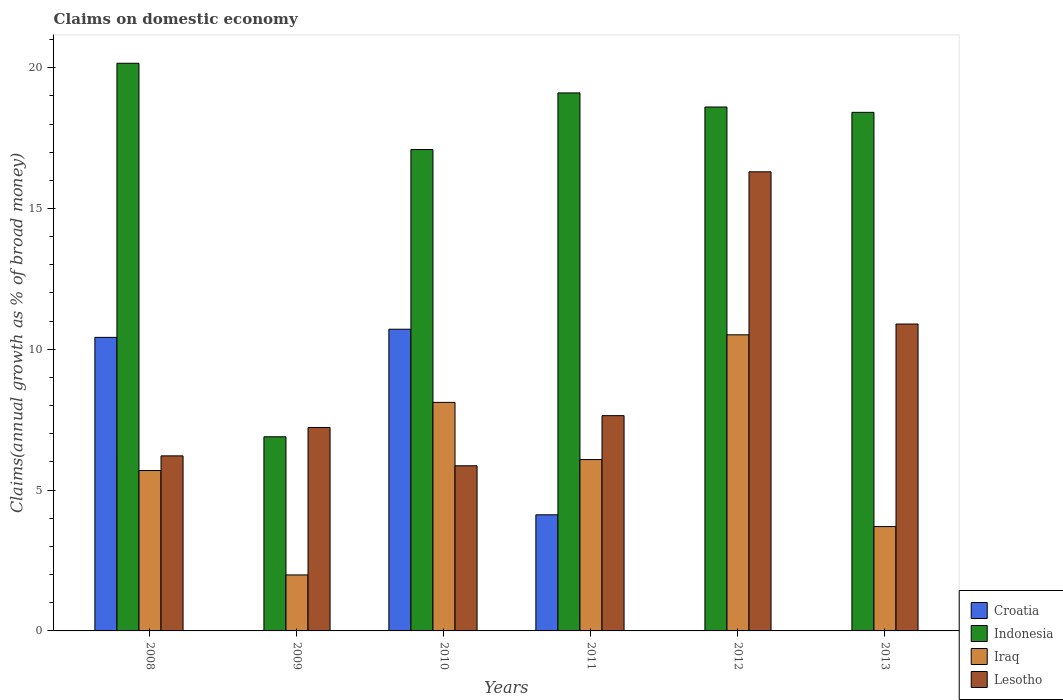How many groups of bars are there?
Offer a very short reply. 6. Are the number of bars on each tick of the X-axis equal?
Your answer should be compact. No. How many bars are there on the 4th tick from the right?
Give a very brief answer. 4. What is the label of the 4th group of bars from the left?
Offer a terse response. 2011. What is the percentage of broad money claimed on domestic economy in Croatia in 2011?
Your answer should be compact. 4.12. Across all years, what is the maximum percentage of broad money claimed on domestic economy in Lesotho?
Make the answer very short. 16.3. Across all years, what is the minimum percentage of broad money claimed on domestic economy in Lesotho?
Your answer should be compact. 5.86. In which year was the percentage of broad money claimed on domestic economy in Iraq maximum?
Your answer should be very brief. 2012. What is the total percentage of broad money claimed on domestic economy in Croatia in the graph?
Keep it short and to the point. 25.26. What is the difference between the percentage of broad money claimed on domestic economy in Indonesia in 2010 and that in 2011?
Your answer should be very brief. -2.01. What is the difference between the percentage of broad money claimed on domestic economy in Lesotho in 2012 and the percentage of broad money claimed on domestic economy in Indonesia in 2013?
Offer a very short reply. -2.11. What is the average percentage of broad money claimed on domestic economy in Iraq per year?
Keep it short and to the point. 6.02. In the year 2011, what is the difference between the percentage of broad money claimed on domestic economy in Indonesia and percentage of broad money claimed on domestic economy in Lesotho?
Make the answer very short. 11.46. In how many years, is the percentage of broad money claimed on domestic economy in Croatia greater than 20 %?
Make the answer very short. 0. What is the ratio of the percentage of broad money claimed on domestic economy in Lesotho in 2012 to that in 2013?
Your response must be concise. 1.5. What is the difference between the highest and the second highest percentage of broad money claimed on domestic economy in Indonesia?
Your answer should be compact. 1.05. What is the difference between the highest and the lowest percentage of broad money claimed on domestic economy in Croatia?
Make the answer very short. 10.71. In how many years, is the percentage of broad money claimed on domestic economy in Iraq greater than the average percentage of broad money claimed on domestic economy in Iraq taken over all years?
Ensure brevity in your answer.  3. Is the sum of the percentage of broad money claimed on domestic economy in Iraq in 2008 and 2013 greater than the maximum percentage of broad money claimed on domestic economy in Croatia across all years?
Your answer should be very brief. No. Are all the bars in the graph horizontal?
Ensure brevity in your answer.  No. What is the difference between two consecutive major ticks on the Y-axis?
Ensure brevity in your answer.  5. Are the values on the major ticks of Y-axis written in scientific E-notation?
Provide a short and direct response. No. Where does the legend appear in the graph?
Ensure brevity in your answer.  Bottom right. How are the legend labels stacked?
Make the answer very short. Vertical. What is the title of the graph?
Your response must be concise. Claims on domestic economy. What is the label or title of the X-axis?
Your answer should be very brief. Years. What is the label or title of the Y-axis?
Provide a short and direct response. Claims(annual growth as % of broad money). What is the Claims(annual growth as % of broad money) of Croatia in 2008?
Your response must be concise. 10.42. What is the Claims(annual growth as % of broad money) of Indonesia in 2008?
Offer a very short reply. 20.16. What is the Claims(annual growth as % of broad money) in Iraq in 2008?
Provide a succinct answer. 5.7. What is the Claims(annual growth as % of broad money) of Lesotho in 2008?
Offer a terse response. 6.22. What is the Claims(annual growth as % of broad money) in Croatia in 2009?
Your answer should be compact. 0. What is the Claims(annual growth as % of broad money) of Indonesia in 2009?
Give a very brief answer. 6.89. What is the Claims(annual growth as % of broad money) in Iraq in 2009?
Offer a terse response. 1.99. What is the Claims(annual growth as % of broad money) in Lesotho in 2009?
Give a very brief answer. 7.22. What is the Claims(annual growth as % of broad money) of Croatia in 2010?
Your response must be concise. 10.71. What is the Claims(annual growth as % of broad money) in Indonesia in 2010?
Make the answer very short. 17.1. What is the Claims(annual growth as % of broad money) of Iraq in 2010?
Your response must be concise. 8.12. What is the Claims(annual growth as % of broad money) of Lesotho in 2010?
Provide a short and direct response. 5.86. What is the Claims(annual growth as % of broad money) in Croatia in 2011?
Provide a short and direct response. 4.12. What is the Claims(annual growth as % of broad money) of Indonesia in 2011?
Make the answer very short. 19.1. What is the Claims(annual growth as % of broad money) in Iraq in 2011?
Ensure brevity in your answer.  6.09. What is the Claims(annual growth as % of broad money) in Lesotho in 2011?
Give a very brief answer. 7.64. What is the Claims(annual growth as % of broad money) of Croatia in 2012?
Make the answer very short. 0. What is the Claims(annual growth as % of broad money) in Indonesia in 2012?
Keep it short and to the point. 18.6. What is the Claims(annual growth as % of broad money) of Iraq in 2012?
Provide a succinct answer. 10.51. What is the Claims(annual growth as % of broad money) of Lesotho in 2012?
Provide a short and direct response. 16.3. What is the Claims(annual growth as % of broad money) of Croatia in 2013?
Ensure brevity in your answer.  0. What is the Claims(annual growth as % of broad money) in Indonesia in 2013?
Provide a short and direct response. 18.42. What is the Claims(annual growth as % of broad money) in Iraq in 2013?
Keep it short and to the point. 3.71. What is the Claims(annual growth as % of broad money) in Lesotho in 2013?
Your answer should be compact. 10.9. Across all years, what is the maximum Claims(annual growth as % of broad money) in Croatia?
Make the answer very short. 10.71. Across all years, what is the maximum Claims(annual growth as % of broad money) in Indonesia?
Make the answer very short. 20.16. Across all years, what is the maximum Claims(annual growth as % of broad money) of Iraq?
Provide a succinct answer. 10.51. Across all years, what is the maximum Claims(annual growth as % of broad money) in Lesotho?
Give a very brief answer. 16.3. Across all years, what is the minimum Claims(annual growth as % of broad money) of Indonesia?
Give a very brief answer. 6.89. Across all years, what is the minimum Claims(annual growth as % of broad money) of Iraq?
Your answer should be very brief. 1.99. Across all years, what is the minimum Claims(annual growth as % of broad money) of Lesotho?
Make the answer very short. 5.86. What is the total Claims(annual growth as % of broad money) of Croatia in the graph?
Provide a short and direct response. 25.26. What is the total Claims(annual growth as % of broad money) in Indonesia in the graph?
Your answer should be very brief. 100.27. What is the total Claims(annual growth as % of broad money) in Iraq in the graph?
Make the answer very short. 36.11. What is the total Claims(annual growth as % of broad money) of Lesotho in the graph?
Ensure brevity in your answer.  54.15. What is the difference between the Claims(annual growth as % of broad money) of Indonesia in 2008 and that in 2009?
Your response must be concise. 13.26. What is the difference between the Claims(annual growth as % of broad money) in Iraq in 2008 and that in 2009?
Your response must be concise. 3.71. What is the difference between the Claims(annual growth as % of broad money) in Lesotho in 2008 and that in 2009?
Your response must be concise. -1.01. What is the difference between the Claims(annual growth as % of broad money) in Croatia in 2008 and that in 2010?
Your response must be concise. -0.29. What is the difference between the Claims(annual growth as % of broad money) in Indonesia in 2008 and that in 2010?
Provide a short and direct response. 3.06. What is the difference between the Claims(annual growth as % of broad money) of Iraq in 2008 and that in 2010?
Offer a very short reply. -2.42. What is the difference between the Claims(annual growth as % of broad money) in Lesotho in 2008 and that in 2010?
Offer a very short reply. 0.35. What is the difference between the Claims(annual growth as % of broad money) in Croatia in 2008 and that in 2011?
Your answer should be compact. 6.3. What is the difference between the Claims(annual growth as % of broad money) in Indonesia in 2008 and that in 2011?
Your response must be concise. 1.05. What is the difference between the Claims(annual growth as % of broad money) of Iraq in 2008 and that in 2011?
Provide a short and direct response. -0.39. What is the difference between the Claims(annual growth as % of broad money) of Lesotho in 2008 and that in 2011?
Offer a terse response. -1.43. What is the difference between the Claims(annual growth as % of broad money) in Indonesia in 2008 and that in 2012?
Offer a terse response. 1.55. What is the difference between the Claims(annual growth as % of broad money) in Iraq in 2008 and that in 2012?
Give a very brief answer. -4.82. What is the difference between the Claims(annual growth as % of broad money) of Lesotho in 2008 and that in 2012?
Keep it short and to the point. -10.09. What is the difference between the Claims(annual growth as % of broad money) in Indonesia in 2008 and that in 2013?
Provide a short and direct response. 1.74. What is the difference between the Claims(annual growth as % of broad money) of Iraq in 2008 and that in 2013?
Ensure brevity in your answer.  1.99. What is the difference between the Claims(annual growth as % of broad money) in Lesotho in 2008 and that in 2013?
Offer a terse response. -4.68. What is the difference between the Claims(annual growth as % of broad money) in Indonesia in 2009 and that in 2010?
Make the answer very short. -10.2. What is the difference between the Claims(annual growth as % of broad money) in Iraq in 2009 and that in 2010?
Provide a succinct answer. -6.13. What is the difference between the Claims(annual growth as % of broad money) in Lesotho in 2009 and that in 2010?
Provide a short and direct response. 1.36. What is the difference between the Claims(annual growth as % of broad money) in Indonesia in 2009 and that in 2011?
Keep it short and to the point. -12.21. What is the difference between the Claims(annual growth as % of broad money) in Iraq in 2009 and that in 2011?
Give a very brief answer. -4.1. What is the difference between the Claims(annual growth as % of broad money) of Lesotho in 2009 and that in 2011?
Your answer should be very brief. -0.42. What is the difference between the Claims(annual growth as % of broad money) in Indonesia in 2009 and that in 2012?
Provide a short and direct response. -11.71. What is the difference between the Claims(annual growth as % of broad money) in Iraq in 2009 and that in 2012?
Give a very brief answer. -8.53. What is the difference between the Claims(annual growth as % of broad money) in Lesotho in 2009 and that in 2012?
Your answer should be very brief. -9.08. What is the difference between the Claims(annual growth as % of broad money) of Indonesia in 2009 and that in 2013?
Keep it short and to the point. -11.52. What is the difference between the Claims(annual growth as % of broad money) in Iraq in 2009 and that in 2013?
Give a very brief answer. -1.72. What is the difference between the Claims(annual growth as % of broad money) in Lesotho in 2009 and that in 2013?
Your answer should be very brief. -3.67. What is the difference between the Claims(annual growth as % of broad money) in Croatia in 2010 and that in 2011?
Give a very brief answer. 6.59. What is the difference between the Claims(annual growth as % of broad money) in Indonesia in 2010 and that in 2011?
Provide a short and direct response. -2.01. What is the difference between the Claims(annual growth as % of broad money) of Iraq in 2010 and that in 2011?
Offer a terse response. 2.03. What is the difference between the Claims(annual growth as % of broad money) in Lesotho in 2010 and that in 2011?
Offer a terse response. -1.78. What is the difference between the Claims(annual growth as % of broad money) of Indonesia in 2010 and that in 2012?
Keep it short and to the point. -1.51. What is the difference between the Claims(annual growth as % of broad money) in Iraq in 2010 and that in 2012?
Your answer should be very brief. -2.4. What is the difference between the Claims(annual growth as % of broad money) of Lesotho in 2010 and that in 2012?
Give a very brief answer. -10.44. What is the difference between the Claims(annual growth as % of broad money) in Indonesia in 2010 and that in 2013?
Your answer should be compact. -1.32. What is the difference between the Claims(annual growth as % of broad money) in Iraq in 2010 and that in 2013?
Offer a very short reply. 4.41. What is the difference between the Claims(annual growth as % of broad money) of Lesotho in 2010 and that in 2013?
Offer a very short reply. -5.03. What is the difference between the Claims(annual growth as % of broad money) of Iraq in 2011 and that in 2012?
Give a very brief answer. -4.43. What is the difference between the Claims(annual growth as % of broad money) in Lesotho in 2011 and that in 2012?
Make the answer very short. -8.66. What is the difference between the Claims(annual growth as % of broad money) in Indonesia in 2011 and that in 2013?
Your response must be concise. 0.69. What is the difference between the Claims(annual growth as % of broad money) of Iraq in 2011 and that in 2013?
Provide a succinct answer. 2.38. What is the difference between the Claims(annual growth as % of broad money) of Lesotho in 2011 and that in 2013?
Make the answer very short. -3.25. What is the difference between the Claims(annual growth as % of broad money) in Indonesia in 2012 and that in 2013?
Offer a very short reply. 0.19. What is the difference between the Claims(annual growth as % of broad money) in Iraq in 2012 and that in 2013?
Offer a terse response. 6.81. What is the difference between the Claims(annual growth as % of broad money) in Lesotho in 2012 and that in 2013?
Give a very brief answer. 5.41. What is the difference between the Claims(annual growth as % of broad money) in Croatia in 2008 and the Claims(annual growth as % of broad money) in Indonesia in 2009?
Offer a terse response. 3.53. What is the difference between the Claims(annual growth as % of broad money) in Croatia in 2008 and the Claims(annual growth as % of broad money) in Iraq in 2009?
Provide a short and direct response. 8.44. What is the difference between the Claims(annual growth as % of broad money) of Croatia in 2008 and the Claims(annual growth as % of broad money) of Lesotho in 2009?
Your answer should be compact. 3.2. What is the difference between the Claims(annual growth as % of broad money) of Indonesia in 2008 and the Claims(annual growth as % of broad money) of Iraq in 2009?
Provide a succinct answer. 18.17. What is the difference between the Claims(annual growth as % of broad money) of Indonesia in 2008 and the Claims(annual growth as % of broad money) of Lesotho in 2009?
Your answer should be very brief. 12.93. What is the difference between the Claims(annual growth as % of broad money) in Iraq in 2008 and the Claims(annual growth as % of broad money) in Lesotho in 2009?
Ensure brevity in your answer.  -1.53. What is the difference between the Claims(annual growth as % of broad money) in Croatia in 2008 and the Claims(annual growth as % of broad money) in Indonesia in 2010?
Give a very brief answer. -6.67. What is the difference between the Claims(annual growth as % of broad money) of Croatia in 2008 and the Claims(annual growth as % of broad money) of Iraq in 2010?
Give a very brief answer. 2.31. What is the difference between the Claims(annual growth as % of broad money) in Croatia in 2008 and the Claims(annual growth as % of broad money) in Lesotho in 2010?
Provide a succinct answer. 4.56. What is the difference between the Claims(annual growth as % of broad money) in Indonesia in 2008 and the Claims(annual growth as % of broad money) in Iraq in 2010?
Your answer should be very brief. 12.04. What is the difference between the Claims(annual growth as % of broad money) in Indonesia in 2008 and the Claims(annual growth as % of broad money) in Lesotho in 2010?
Your answer should be compact. 14.29. What is the difference between the Claims(annual growth as % of broad money) of Iraq in 2008 and the Claims(annual growth as % of broad money) of Lesotho in 2010?
Offer a very short reply. -0.17. What is the difference between the Claims(annual growth as % of broad money) in Croatia in 2008 and the Claims(annual growth as % of broad money) in Indonesia in 2011?
Your answer should be very brief. -8.68. What is the difference between the Claims(annual growth as % of broad money) of Croatia in 2008 and the Claims(annual growth as % of broad money) of Iraq in 2011?
Provide a succinct answer. 4.34. What is the difference between the Claims(annual growth as % of broad money) in Croatia in 2008 and the Claims(annual growth as % of broad money) in Lesotho in 2011?
Your response must be concise. 2.78. What is the difference between the Claims(annual growth as % of broad money) in Indonesia in 2008 and the Claims(annual growth as % of broad money) in Iraq in 2011?
Your response must be concise. 14.07. What is the difference between the Claims(annual growth as % of broad money) in Indonesia in 2008 and the Claims(annual growth as % of broad money) in Lesotho in 2011?
Provide a short and direct response. 12.51. What is the difference between the Claims(annual growth as % of broad money) in Iraq in 2008 and the Claims(annual growth as % of broad money) in Lesotho in 2011?
Provide a short and direct response. -1.95. What is the difference between the Claims(annual growth as % of broad money) in Croatia in 2008 and the Claims(annual growth as % of broad money) in Indonesia in 2012?
Offer a very short reply. -8.18. What is the difference between the Claims(annual growth as % of broad money) of Croatia in 2008 and the Claims(annual growth as % of broad money) of Iraq in 2012?
Offer a terse response. -0.09. What is the difference between the Claims(annual growth as % of broad money) in Croatia in 2008 and the Claims(annual growth as % of broad money) in Lesotho in 2012?
Provide a succinct answer. -5.88. What is the difference between the Claims(annual growth as % of broad money) of Indonesia in 2008 and the Claims(annual growth as % of broad money) of Iraq in 2012?
Your response must be concise. 9.64. What is the difference between the Claims(annual growth as % of broad money) of Indonesia in 2008 and the Claims(annual growth as % of broad money) of Lesotho in 2012?
Offer a very short reply. 3.85. What is the difference between the Claims(annual growth as % of broad money) in Iraq in 2008 and the Claims(annual growth as % of broad money) in Lesotho in 2012?
Offer a terse response. -10.61. What is the difference between the Claims(annual growth as % of broad money) of Croatia in 2008 and the Claims(annual growth as % of broad money) of Indonesia in 2013?
Provide a short and direct response. -7.99. What is the difference between the Claims(annual growth as % of broad money) in Croatia in 2008 and the Claims(annual growth as % of broad money) in Iraq in 2013?
Ensure brevity in your answer.  6.72. What is the difference between the Claims(annual growth as % of broad money) in Croatia in 2008 and the Claims(annual growth as % of broad money) in Lesotho in 2013?
Keep it short and to the point. -0.47. What is the difference between the Claims(annual growth as % of broad money) of Indonesia in 2008 and the Claims(annual growth as % of broad money) of Iraq in 2013?
Your response must be concise. 16.45. What is the difference between the Claims(annual growth as % of broad money) in Indonesia in 2008 and the Claims(annual growth as % of broad money) in Lesotho in 2013?
Provide a succinct answer. 9.26. What is the difference between the Claims(annual growth as % of broad money) of Iraq in 2008 and the Claims(annual growth as % of broad money) of Lesotho in 2013?
Keep it short and to the point. -5.2. What is the difference between the Claims(annual growth as % of broad money) in Indonesia in 2009 and the Claims(annual growth as % of broad money) in Iraq in 2010?
Offer a very short reply. -1.22. What is the difference between the Claims(annual growth as % of broad money) of Indonesia in 2009 and the Claims(annual growth as % of broad money) of Lesotho in 2010?
Provide a succinct answer. 1.03. What is the difference between the Claims(annual growth as % of broad money) of Iraq in 2009 and the Claims(annual growth as % of broad money) of Lesotho in 2010?
Ensure brevity in your answer.  -3.88. What is the difference between the Claims(annual growth as % of broad money) of Indonesia in 2009 and the Claims(annual growth as % of broad money) of Iraq in 2011?
Provide a succinct answer. 0.81. What is the difference between the Claims(annual growth as % of broad money) in Indonesia in 2009 and the Claims(annual growth as % of broad money) in Lesotho in 2011?
Your answer should be compact. -0.75. What is the difference between the Claims(annual growth as % of broad money) in Iraq in 2009 and the Claims(annual growth as % of broad money) in Lesotho in 2011?
Your response must be concise. -5.66. What is the difference between the Claims(annual growth as % of broad money) of Indonesia in 2009 and the Claims(annual growth as % of broad money) of Iraq in 2012?
Your response must be concise. -3.62. What is the difference between the Claims(annual growth as % of broad money) of Indonesia in 2009 and the Claims(annual growth as % of broad money) of Lesotho in 2012?
Make the answer very short. -9.41. What is the difference between the Claims(annual growth as % of broad money) in Iraq in 2009 and the Claims(annual growth as % of broad money) in Lesotho in 2012?
Your answer should be compact. -14.32. What is the difference between the Claims(annual growth as % of broad money) in Indonesia in 2009 and the Claims(annual growth as % of broad money) in Iraq in 2013?
Keep it short and to the point. 3.19. What is the difference between the Claims(annual growth as % of broad money) of Indonesia in 2009 and the Claims(annual growth as % of broad money) of Lesotho in 2013?
Ensure brevity in your answer.  -4. What is the difference between the Claims(annual growth as % of broad money) of Iraq in 2009 and the Claims(annual growth as % of broad money) of Lesotho in 2013?
Make the answer very short. -8.91. What is the difference between the Claims(annual growth as % of broad money) in Croatia in 2010 and the Claims(annual growth as % of broad money) in Indonesia in 2011?
Your answer should be very brief. -8.39. What is the difference between the Claims(annual growth as % of broad money) of Croatia in 2010 and the Claims(annual growth as % of broad money) of Iraq in 2011?
Your response must be concise. 4.63. What is the difference between the Claims(annual growth as % of broad money) in Croatia in 2010 and the Claims(annual growth as % of broad money) in Lesotho in 2011?
Provide a short and direct response. 3.07. What is the difference between the Claims(annual growth as % of broad money) in Indonesia in 2010 and the Claims(annual growth as % of broad money) in Iraq in 2011?
Your answer should be compact. 11.01. What is the difference between the Claims(annual growth as % of broad money) in Indonesia in 2010 and the Claims(annual growth as % of broad money) in Lesotho in 2011?
Give a very brief answer. 9.45. What is the difference between the Claims(annual growth as % of broad money) in Iraq in 2010 and the Claims(annual growth as % of broad money) in Lesotho in 2011?
Your answer should be compact. 0.47. What is the difference between the Claims(annual growth as % of broad money) in Croatia in 2010 and the Claims(annual growth as % of broad money) in Indonesia in 2012?
Keep it short and to the point. -7.89. What is the difference between the Claims(annual growth as % of broad money) of Croatia in 2010 and the Claims(annual growth as % of broad money) of Iraq in 2012?
Ensure brevity in your answer.  0.2. What is the difference between the Claims(annual growth as % of broad money) of Croatia in 2010 and the Claims(annual growth as % of broad money) of Lesotho in 2012?
Keep it short and to the point. -5.59. What is the difference between the Claims(annual growth as % of broad money) in Indonesia in 2010 and the Claims(annual growth as % of broad money) in Iraq in 2012?
Your answer should be compact. 6.58. What is the difference between the Claims(annual growth as % of broad money) of Indonesia in 2010 and the Claims(annual growth as % of broad money) of Lesotho in 2012?
Keep it short and to the point. 0.79. What is the difference between the Claims(annual growth as % of broad money) of Iraq in 2010 and the Claims(annual growth as % of broad money) of Lesotho in 2012?
Keep it short and to the point. -8.19. What is the difference between the Claims(annual growth as % of broad money) of Croatia in 2010 and the Claims(annual growth as % of broad money) of Indonesia in 2013?
Your answer should be compact. -7.7. What is the difference between the Claims(annual growth as % of broad money) in Croatia in 2010 and the Claims(annual growth as % of broad money) in Iraq in 2013?
Keep it short and to the point. 7.01. What is the difference between the Claims(annual growth as % of broad money) of Croatia in 2010 and the Claims(annual growth as % of broad money) of Lesotho in 2013?
Make the answer very short. -0.18. What is the difference between the Claims(annual growth as % of broad money) in Indonesia in 2010 and the Claims(annual growth as % of broad money) in Iraq in 2013?
Your answer should be very brief. 13.39. What is the difference between the Claims(annual growth as % of broad money) of Indonesia in 2010 and the Claims(annual growth as % of broad money) of Lesotho in 2013?
Make the answer very short. 6.2. What is the difference between the Claims(annual growth as % of broad money) in Iraq in 2010 and the Claims(annual growth as % of broad money) in Lesotho in 2013?
Your answer should be compact. -2.78. What is the difference between the Claims(annual growth as % of broad money) in Croatia in 2011 and the Claims(annual growth as % of broad money) in Indonesia in 2012?
Offer a very short reply. -14.48. What is the difference between the Claims(annual growth as % of broad money) in Croatia in 2011 and the Claims(annual growth as % of broad money) in Iraq in 2012?
Offer a terse response. -6.39. What is the difference between the Claims(annual growth as % of broad money) in Croatia in 2011 and the Claims(annual growth as % of broad money) in Lesotho in 2012?
Your answer should be compact. -12.18. What is the difference between the Claims(annual growth as % of broad money) in Indonesia in 2011 and the Claims(annual growth as % of broad money) in Iraq in 2012?
Give a very brief answer. 8.59. What is the difference between the Claims(annual growth as % of broad money) in Indonesia in 2011 and the Claims(annual growth as % of broad money) in Lesotho in 2012?
Your answer should be compact. 2.8. What is the difference between the Claims(annual growth as % of broad money) in Iraq in 2011 and the Claims(annual growth as % of broad money) in Lesotho in 2012?
Your answer should be compact. -10.22. What is the difference between the Claims(annual growth as % of broad money) in Croatia in 2011 and the Claims(annual growth as % of broad money) in Indonesia in 2013?
Your answer should be very brief. -14.29. What is the difference between the Claims(annual growth as % of broad money) in Croatia in 2011 and the Claims(annual growth as % of broad money) in Iraq in 2013?
Ensure brevity in your answer.  0.42. What is the difference between the Claims(annual growth as % of broad money) in Croatia in 2011 and the Claims(annual growth as % of broad money) in Lesotho in 2013?
Your response must be concise. -6.77. What is the difference between the Claims(annual growth as % of broad money) of Indonesia in 2011 and the Claims(annual growth as % of broad money) of Iraq in 2013?
Provide a succinct answer. 15.4. What is the difference between the Claims(annual growth as % of broad money) in Indonesia in 2011 and the Claims(annual growth as % of broad money) in Lesotho in 2013?
Your response must be concise. 8.21. What is the difference between the Claims(annual growth as % of broad money) of Iraq in 2011 and the Claims(annual growth as % of broad money) of Lesotho in 2013?
Your answer should be very brief. -4.81. What is the difference between the Claims(annual growth as % of broad money) of Indonesia in 2012 and the Claims(annual growth as % of broad money) of Iraq in 2013?
Give a very brief answer. 14.9. What is the difference between the Claims(annual growth as % of broad money) of Indonesia in 2012 and the Claims(annual growth as % of broad money) of Lesotho in 2013?
Ensure brevity in your answer.  7.71. What is the difference between the Claims(annual growth as % of broad money) in Iraq in 2012 and the Claims(annual growth as % of broad money) in Lesotho in 2013?
Offer a terse response. -0.38. What is the average Claims(annual growth as % of broad money) in Croatia per year?
Ensure brevity in your answer.  4.21. What is the average Claims(annual growth as % of broad money) of Indonesia per year?
Ensure brevity in your answer.  16.71. What is the average Claims(annual growth as % of broad money) in Iraq per year?
Keep it short and to the point. 6.02. What is the average Claims(annual growth as % of broad money) in Lesotho per year?
Keep it short and to the point. 9.03. In the year 2008, what is the difference between the Claims(annual growth as % of broad money) in Croatia and Claims(annual growth as % of broad money) in Indonesia?
Your response must be concise. -9.73. In the year 2008, what is the difference between the Claims(annual growth as % of broad money) in Croatia and Claims(annual growth as % of broad money) in Iraq?
Offer a terse response. 4.73. In the year 2008, what is the difference between the Claims(annual growth as % of broad money) in Croatia and Claims(annual growth as % of broad money) in Lesotho?
Your response must be concise. 4.21. In the year 2008, what is the difference between the Claims(annual growth as % of broad money) in Indonesia and Claims(annual growth as % of broad money) in Iraq?
Your answer should be very brief. 14.46. In the year 2008, what is the difference between the Claims(annual growth as % of broad money) in Indonesia and Claims(annual growth as % of broad money) in Lesotho?
Offer a very short reply. 13.94. In the year 2008, what is the difference between the Claims(annual growth as % of broad money) of Iraq and Claims(annual growth as % of broad money) of Lesotho?
Offer a very short reply. -0.52. In the year 2009, what is the difference between the Claims(annual growth as % of broad money) of Indonesia and Claims(annual growth as % of broad money) of Iraq?
Offer a terse response. 4.91. In the year 2009, what is the difference between the Claims(annual growth as % of broad money) in Indonesia and Claims(annual growth as % of broad money) in Lesotho?
Ensure brevity in your answer.  -0.33. In the year 2009, what is the difference between the Claims(annual growth as % of broad money) in Iraq and Claims(annual growth as % of broad money) in Lesotho?
Keep it short and to the point. -5.24. In the year 2010, what is the difference between the Claims(annual growth as % of broad money) in Croatia and Claims(annual growth as % of broad money) in Indonesia?
Make the answer very short. -6.38. In the year 2010, what is the difference between the Claims(annual growth as % of broad money) of Croatia and Claims(annual growth as % of broad money) of Iraq?
Offer a very short reply. 2.6. In the year 2010, what is the difference between the Claims(annual growth as % of broad money) of Croatia and Claims(annual growth as % of broad money) of Lesotho?
Your answer should be very brief. 4.85. In the year 2010, what is the difference between the Claims(annual growth as % of broad money) of Indonesia and Claims(annual growth as % of broad money) of Iraq?
Offer a terse response. 8.98. In the year 2010, what is the difference between the Claims(annual growth as % of broad money) in Indonesia and Claims(annual growth as % of broad money) in Lesotho?
Your answer should be very brief. 11.23. In the year 2010, what is the difference between the Claims(annual growth as % of broad money) in Iraq and Claims(annual growth as % of broad money) in Lesotho?
Provide a short and direct response. 2.25. In the year 2011, what is the difference between the Claims(annual growth as % of broad money) in Croatia and Claims(annual growth as % of broad money) in Indonesia?
Your response must be concise. -14.98. In the year 2011, what is the difference between the Claims(annual growth as % of broad money) of Croatia and Claims(annual growth as % of broad money) of Iraq?
Offer a very short reply. -1.96. In the year 2011, what is the difference between the Claims(annual growth as % of broad money) of Croatia and Claims(annual growth as % of broad money) of Lesotho?
Give a very brief answer. -3.52. In the year 2011, what is the difference between the Claims(annual growth as % of broad money) in Indonesia and Claims(annual growth as % of broad money) in Iraq?
Your answer should be compact. 13.02. In the year 2011, what is the difference between the Claims(annual growth as % of broad money) in Indonesia and Claims(annual growth as % of broad money) in Lesotho?
Keep it short and to the point. 11.46. In the year 2011, what is the difference between the Claims(annual growth as % of broad money) in Iraq and Claims(annual growth as % of broad money) in Lesotho?
Your answer should be compact. -1.56. In the year 2012, what is the difference between the Claims(annual growth as % of broad money) in Indonesia and Claims(annual growth as % of broad money) in Iraq?
Offer a terse response. 8.09. In the year 2012, what is the difference between the Claims(annual growth as % of broad money) of Indonesia and Claims(annual growth as % of broad money) of Lesotho?
Your answer should be very brief. 2.3. In the year 2012, what is the difference between the Claims(annual growth as % of broad money) of Iraq and Claims(annual growth as % of broad money) of Lesotho?
Your response must be concise. -5.79. In the year 2013, what is the difference between the Claims(annual growth as % of broad money) in Indonesia and Claims(annual growth as % of broad money) in Iraq?
Make the answer very short. 14.71. In the year 2013, what is the difference between the Claims(annual growth as % of broad money) in Indonesia and Claims(annual growth as % of broad money) in Lesotho?
Offer a terse response. 7.52. In the year 2013, what is the difference between the Claims(annual growth as % of broad money) in Iraq and Claims(annual growth as % of broad money) in Lesotho?
Give a very brief answer. -7.19. What is the ratio of the Claims(annual growth as % of broad money) in Indonesia in 2008 to that in 2009?
Make the answer very short. 2.92. What is the ratio of the Claims(annual growth as % of broad money) in Iraq in 2008 to that in 2009?
Give a very brief answer. 2.86. What is the ratio of the Claims(annual growth as % of broad money) of Lesotho in 2008 to that in 2009?
Give a very brief answer. 0.86. What is the ratio of the Claims(annual growth as % of broad money) in Croatia in 2008 to that in 2010?
Your response must be concise. 0.97. What is the ratio of the Claims(annual growth as % of broad money) of Indonesia in 2008 to that in 2010?
Your answer should be very brief. 1.18. What is the ratio of the Claims(annual growth as % of broad money) of Iraq in 2008 to that in 2010?
Offer a very short reply. 0.7. What is the ratio of the Claims(annual growth as % of broad money) of Lesotho in 2008 to that in 2010?
Provide a short and direct response. 1.06. What is the ratio of the Claims(annual growth as % of broad money) of Croatia in 2008 to that in 2011?
Your answer should be compact. 2.53. What is the ratio of the Claims(annual growth as % of broad money) of Indonesia in 2008 to that in 2011?
Give a very brief answer. 1.06. What is the ratio of the Claims(annual growth as % of broad money) in Iraq in 2008 to that in 2011?
Provide a succinct answer. 0.94. What is the ratio of the Claims(annual growth as % of broad money) in Lesotho in 2008 to that in 2011?
Give a very brief answer. 0.81. What is the ratio of the Claims(annual growth as % of broad money) in Indonesia in 2008 to that in 2012?
Ensure brevity in your answer.  1.08. What is the ratio of the Claims(annual growth as % of broad money) in Iraq in 2008 to that in 2012?
Your answer should be very brief. 0.54. What is the ratio of the Claims(annual growth as % of broad money) of Lesotho in 2008 to that in 2012?
Your answer should be compact. 0.38. What is the ratio of the Claims(annual growth as % of broad money) in Indonesia in 2008 to that in 2013?
Offer a very short reply. 1.09. What is the ratio of the Claims(annual growth as % of broad money) of Iraq in 2008 to that in 2013?
Give a very brief answer. 1.54. What is the ratio of the Claims(annual growth as % of broad money) in Lesotho in 2008 to that in 2013?
Make the answer very short. 0.57. What is the ratio of the Claims(annual growth as % of broad money) in Indonesia in 2009 to that in 2010?
Offer a very short reply. 0.4. What is the ratio of the Claims(annual growth as % of broad money) in Iraq in 2009 to that in 2010?
Your answer should be compact. 0.24. What is the ratio of the Claims(annual growth as % of broad money) of Lesotho in 2009 to that in 2010?
Provide a succinct answer. 1.23. What is the ratio of the Claims(annual growth as % of broad money) in Indonesia in 2009 to that in 2011?
Offer a very short reply. 0.36. What is the ratio of the Claims(annual growth as % of broad money) in Iraq in 2009 to that in 2011?
Ensure brevity in your answer.  0.33. What is the ratio of the Claims(annual growth as % of broad money) of Lesotho in 2009 to that in 2011?
Make the answer very short. 0.95. What is the ratio of the Claims(annual growth as % of broad money) in Indonesia in 2009 to that in 2012?
Keep it short and to the point. 0.37. What is the ratio of the Claims(annual growth as % of broad money) in Iraq in 2009 to that in 2012?
Your answer should be compact. 0.19. What is the ratio of the Claims(annual growth as % of broad money) of Lesotho in 2009 to that in 2012?
Give a very brief answer. 0.44. What is the ratio of the Claims(annual growth as % of broad money) in Indonesia in 2009 to that in 2013?
Ensure brevity in your answer.  0.37. What is the ratio of the Claims(annual growth as % of broad money) of Iraq in 2009 to that in 2013?
Provide a short and direct response. 0.54. What is the ratio of the Claims(annual growth as % of broad money) in Lesotho in 2009 to that in 2013?
Offer a terse response. 0.66. What is the ratio of the Claims(annual growth as % of broad money) in Croatia in 2010 to that in 2011?
Ensure brevity in your answer.  2.6. What is the ratio of the Claims(annual growth as % of broad money) in Indonesia in 2010 to that in 2011?
Give a very brief answer. 0.89. What is the ratio of the Claims(annual growth as % of broad money) of Iraq in 2010 to that in 2011?
Provide a succinct answer. 1.33. What is the ratio of the Claims(annual growth as % of broad money) in Lesotho in 2010 to that in 2011?
Ensure brevity in your answer.  0.77. What is the ratio of the Claims(annual growth as % of broad money) in Indonesia in 2010 to that in 2012?
Make the answer very short. 0.92. What is the ratio of the Claims(annual growth as % of broad money) of Iraq in 2010 to that in 2012?
Your answer should be very brief. 0.77. What is the ratio of the Claims(annual growth as % of broad money) of Lesotho in 2010 to that in 2012?
Provide a succinct answer. 0.36. What is the ratio of the Claims(annual growth as % of broad money) in Indonesia in 2010 to that in 2013?
Give a very brief answer. 0.93. What is the ratio of the Claims(annual growth as % of broad money) in Iraq in 2010 to that in 2013?
Make the answer very short. 2.19. What is the ratio of the Claims(annual growth as % of broad money) of Lesotho in 2010 to that in 2013?
Your answer should be very brief. 0.54. What is the ratio of the Claims(annual growth as % of broad money) in Indonesia in 2011 to that in 2012?
Make the answer very short. 1.03. What is the ratio of the Claims(annual growth as % of broad money) of Iraq in 2011 to that in 2012?
Your answer should be very brief. 0.58. What is the ratio of the Claims(annual growth as % of broad money) of Lesotho in 2011 to that in 2012?
Your response must be concise. 0.47. What is the ratio of the Claims(annual growth as % of broad money) of Indonesia in 2011 to that in 2013?
Offer a very short reply. 1.04. What is the ratio of the Claims(annual growth as % of broad money) in Iraq in 2011 to that in 2013?
Make the answer very short. 1.64. What is the ratio of the Claims(annual growth as % of broad money) of Lesotho in 2011 to that in 2013?
Offer a very short reply. 0.7. What is the ratio of the Claims(annual growth as % of broad money) of Indonesia in 2012 to that in 2013?
Ensure brevity in your answer.  1.01. What is the ratio of the Claims(annual growth as % of broad money) of Iraq in 2012 to that in 2013?
Keep it short and to the point. 2.84. What is the ratio of the Claims(annual growth as % of broad money) in Lesotho in 2012 to that in 2013?
Your response must be concise. 1.5. What is the difference between the highest and the second highest Claims(annual growth as % of broad money) in Croatia?
Offer a very short reply. 0.29. What is the difference between the highest and the second highest Claims(annual growth as % of broad money) of Indonesia?
Make the answer very short. 1.05. What is the difference between the highest and the second highest Claims(annual growth as % of broad money) in Iraq?
Keep it short and to the point. 2.4. What is the difference between the highest and the second highest Claims(annual growth as % of broad money) of Lesotho?
Make the answer very short. 5.41. What is the difference between the highest and the lowest Claims(annual growth as % of broad money) in Croatia?
Your answer should be very brief. 10.71. What is the difference between the highest and the lowest Claims(annual growth as % of broad money) of Indonesia?
Offer a very short reply. 13.26. What is the difference between the highest and the lowest Claims(annual growth as % of broad money) in Iraq?
Your response must be concise. 8.53. What is the difference between the highest and the lowest Claims(annual growth as % of broad money) in Lesotho?
Offer a terse response. 10.44. 